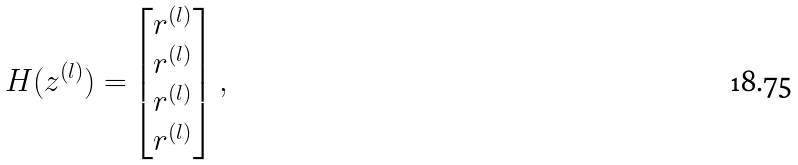<formula> <loc_0><loc_0><loc_500><loc_500>H ( z ^ { ( l ) } ) = & \begin{bmatrix} r ^ { ( l ) } \\ r ^ { ( l ) } \\ r ^ { ( l ) } \\ r ^ { ( l ) } \end{bmatrix} ,</formula> 